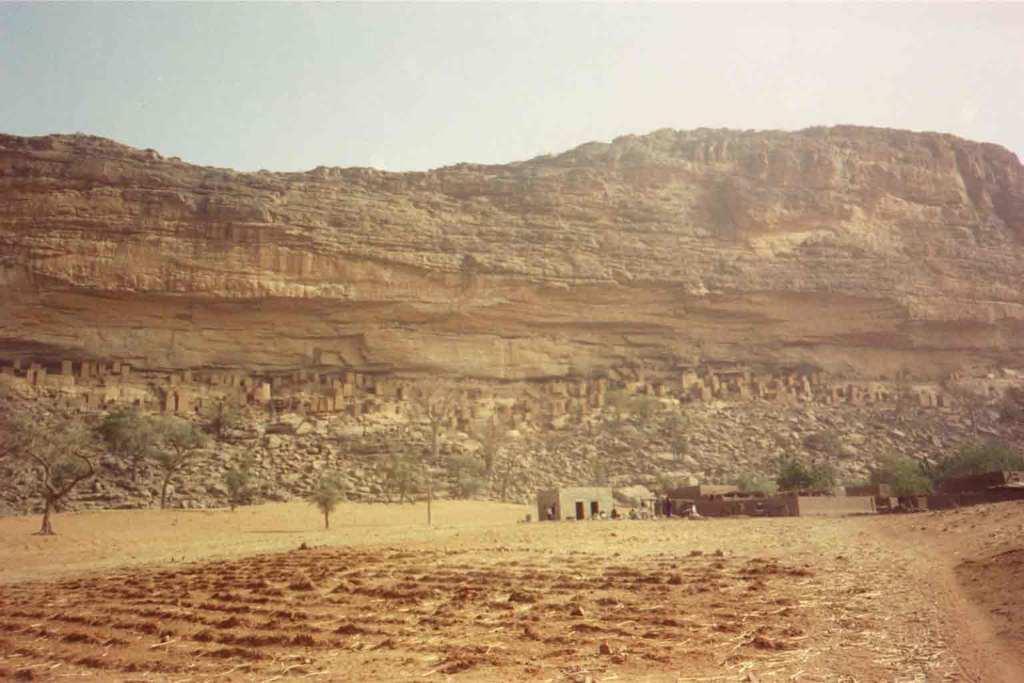Please provide a concise description of this image. There is empty land in the foreground area of the image, there are trees, it seems like houses and stones in the center. There is a huge hill and the sky in the background. 